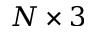<formula> <loc_0><loc_0><loc_500><loc_500>N \times 3</formula> 